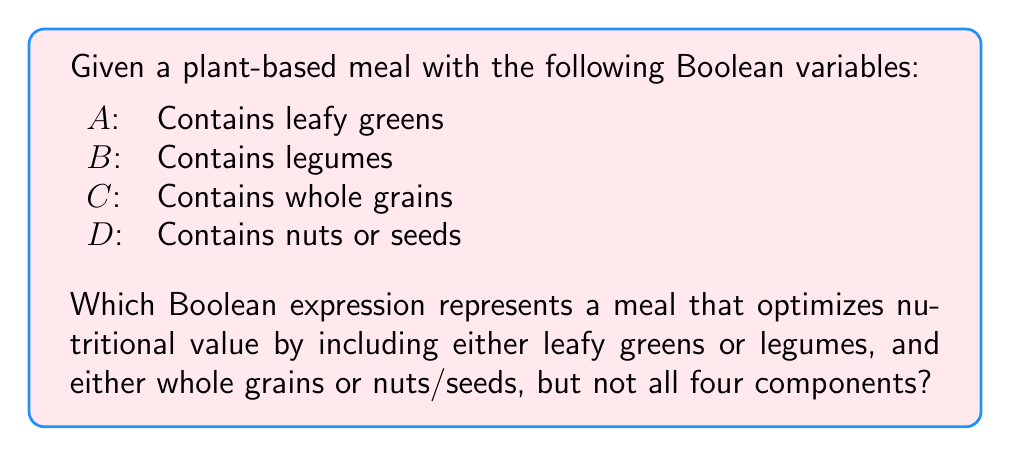Give your solution to this math problem. Let's approach this step-by-step:

1) First, we need to represent "either leafy greens or legumes":
   $$(A \lor B)$$

2) Next, we represent "either whole grains or nuts/seeds":
   $$(C \lor D)$$

3) We want both of these conditions to be true, so we use the AND operator:
   $$(A \lor B) \land (C \lor D)$$

4) However, we don't want all four components. This means we need to exclude the case where all variables are true:
   $$\lnot(A \land B \land C \land D)$$

5) To combine these conditions, we use the AND operator again:
   $$((A \lor B) \land (C \lor D)) \land \lnot(A \land B \land C \land D)$$

This expression represents a meal that includes either leafy greens or legumes, and either whole grains or nuts/seeds, but not all four components, thus optimizing nutritional value while maintaining variety in a plant-based meal.
Answer: $((A \lor B) \land (C \lor D)) \land \lnot(A \land B \land C \land D)$ 